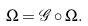<formula> <loc_0><loc_0><loc_500><loc_500>\Omega = \mathcal { G } \circ \Omega .</formula> 